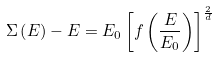Convert formula to latex. <formula><loc_0><loc_0><loc_500><loc_500>\Sigma \left ( E \right ) - E = E _ { 0 } \left [ f \left ( \frac { E } { E _ { 0 } } \right ) \right ] ^ { \frac { 2 } { d } }</formula> 